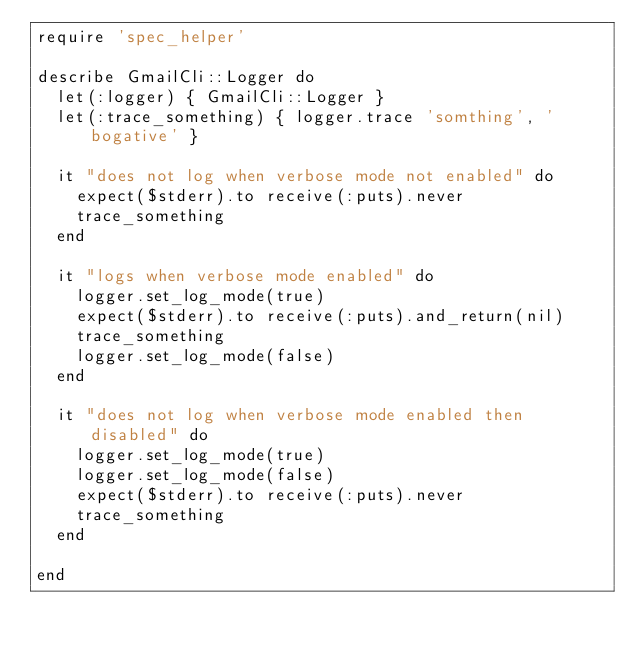Convert code to text. <code><loc_0><loc_0><loc_500><loc_500><_Ruby_>require 'spec_helper'

describe GmailCli::Logger do
  let(:logger) { GmailCli::Logger }
  let(:trace_something) { logger.trace 'somthing', 'bogative' }

  it "does not log when verbose mode not enabled" do
    expect($stderr).to receive(:puts).never
    trace_something
  end

  it "logs when verbose mode enabled" do
    logger.set_log_mode(true)
    expect($stderr).to receive(:puts).and_return(nil)
    trace_something
    logger.set_log_mode(false)
  end

  it "does not log when verbose mode enabled then disabled" do
    logger.set_log_mode(true)
    logger.set_log_mode(false)
    expect($stderr).to receive(:puts).never
    trace_something
  end

end</code> 